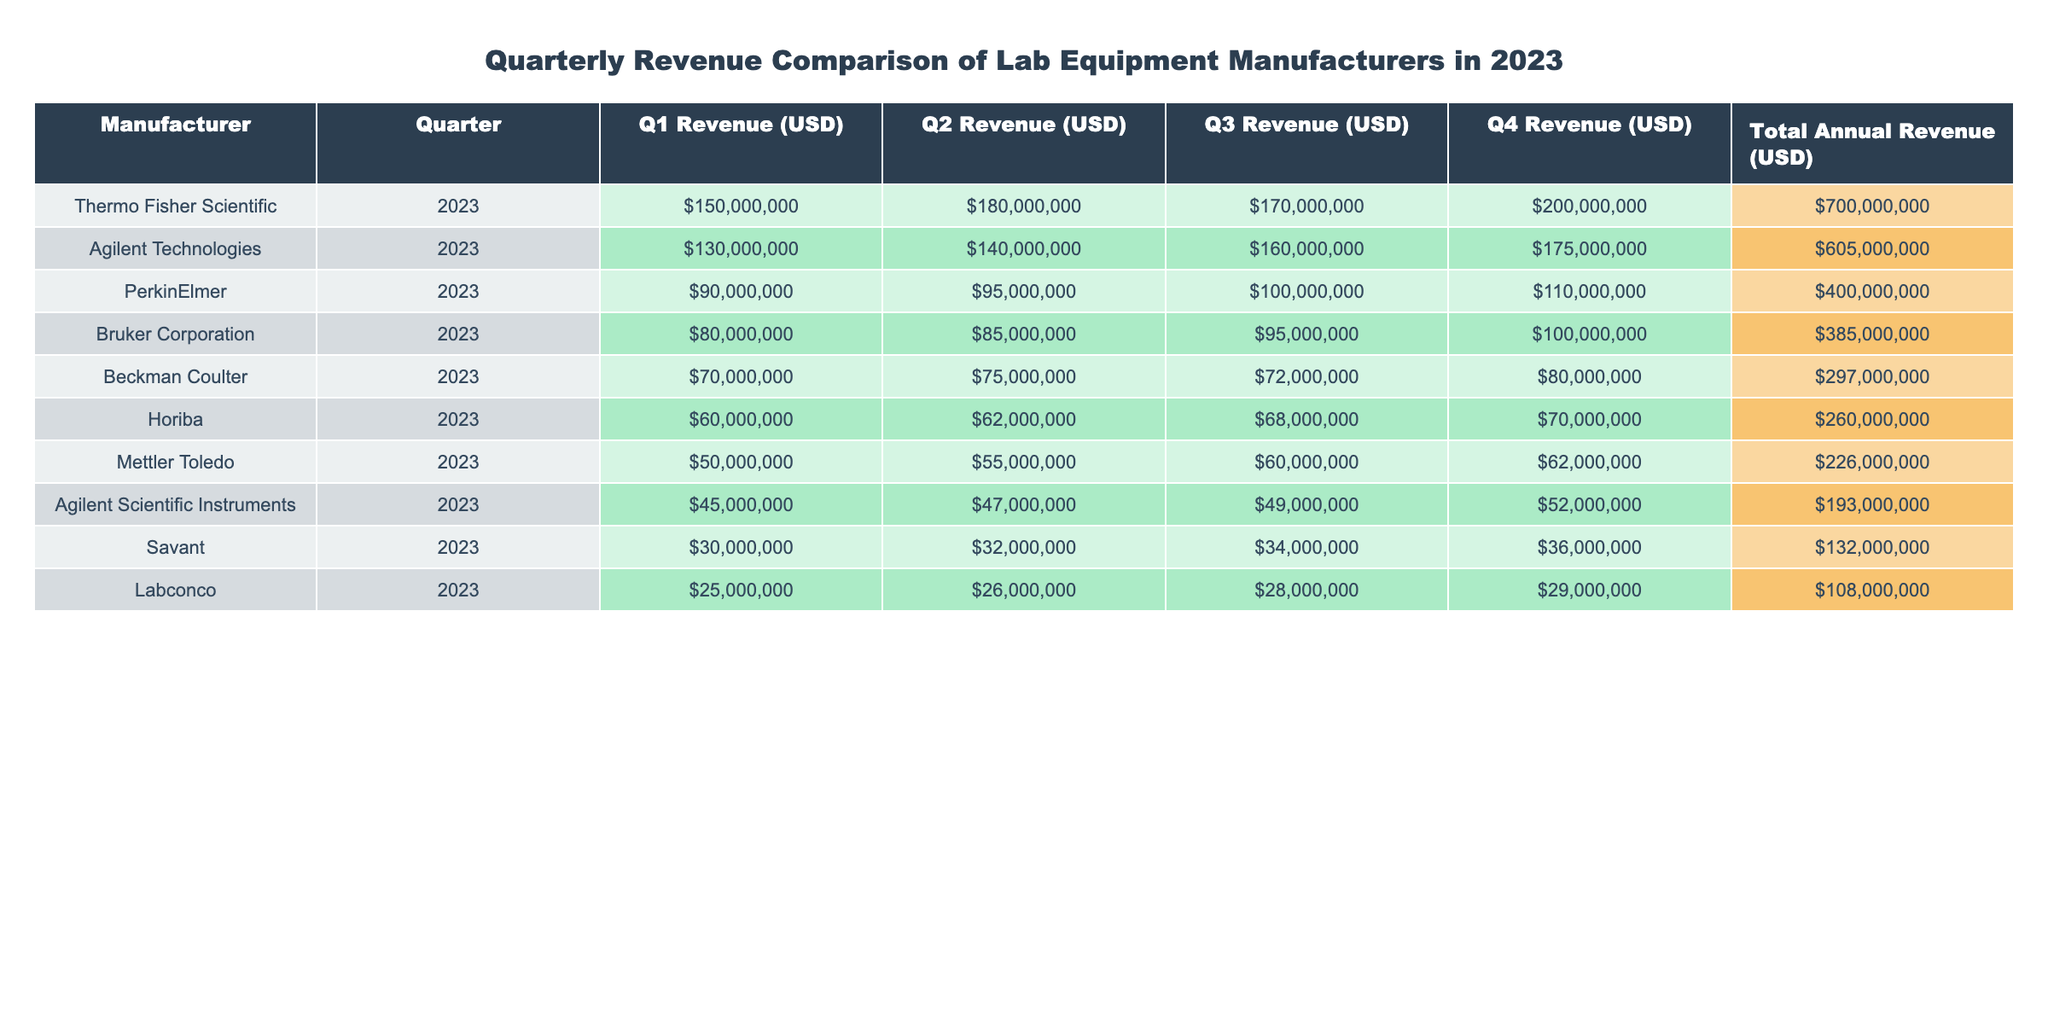What manufacturer had the highest Q1 revenue? By examining the Q1 revenue column, Thermo Fisher Scientific has the highest value at $150,000,000.
Answer: Thermo Fisher Scientific What was the total annual revenue for Agilent Technologies? In the total annual revenue column for Agilent Technologies, the value is $605,000,000.
Answer: $605,000,000 Which manufacturer experienced the lowest Q3 revenue? Looking at the Q3 revenue column, Beckman Coulter had the lowest value at $72,000,000.
Answer: Beckman Coulter What is the Q4 revenue difference between Thermo Fisher Scientific and PerkinElmer? Thermo Fisher Scientific's Q4 revenue is $200,000,000, while PerkinElmer's Q4 revenue is $110,000,000. The difference is $200,000,000 - $110,000,000 = $90,000,000.
Answer: $90,000,000 What's the average revenue for Mettler Toledo across all quarters? The revenue figures for Mettler Toledo are Q1: $50,000,000, Q2: $55,000,000, Q3: $60,000,000, and Q4: $62,000,000. The average is calculated as ($50,000,000 + $55,000,000 + $60,000,000 + $62,000,000) / 4 = $56,750,000.
Answer: $56,750,000 Did Agilent Scientific Instruments surpass Labconco in total annual revenue? Agilent Scientific Instruments has a total annual revenue of $193,000,000, while Labconco has $108,000,000. Since $193,000,000 is greater than $108,000,000, the answer is yes.
Answer: Yes Which manufacturer has the largest difference between Q1 and Q4 revenues? Analyzing the quarterly revenue, Thermo Fisher Scientific's difference is $200,000,000 - $150,000,000 = $50,000,000. Agilent Technologies' difference is $175,000,000 - $130,000,000 = $45,000,000, and so on. After checking all manufacturers, Thermo Fisher Scientific has the largest difference of $50,000,000.
Answer: Thermo Fisher Scientific What was the Q2 revenue of Horiba? By checking the Q2 revenue column for Horiba, the value is $62,000,000.
Answer: $62,000,000 How do the total revenues of Bruker Corporation and Beckman Coulter compare? Bruker Corporation's total revenue is $385,000,000 and Beckman Coulter's is $297,000,000. Comparing these, $385,000,000 is greater than $297,000,000, showing that Bruker Corporation has a higher total revenue.
Answer: Bruker Corporation has a higher total revenue What is the combined total revenue of the three lowest-grossing manufacturers? The total revenues of the three lowest manufacturers (Mettler Toledo, Agilent Scientific Instruments, and Savant) are $226,000,000, $193,000,000, and $132,000,000, respectively. The combined total is $226,000,000 + $193,000,000 + $132,000,000 = $551,000,000.
Answer: $551,000,000 